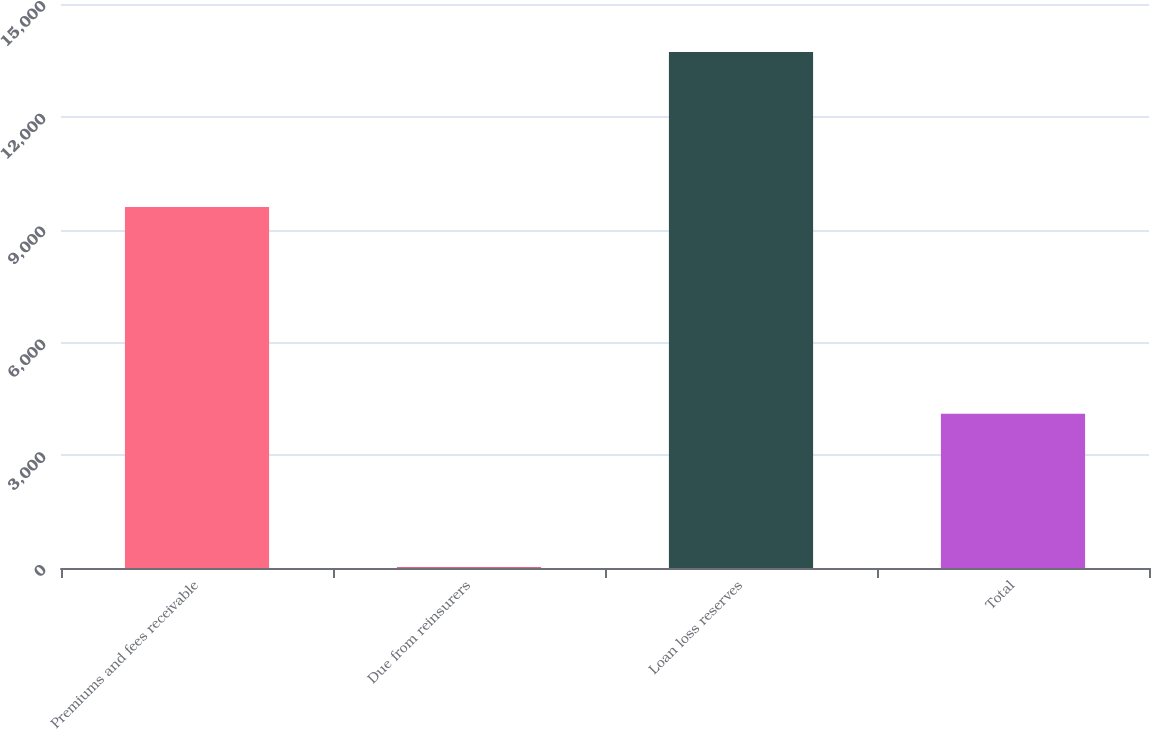<chart> <loc_0><loc_0><loc_500><loc_500><bar_chart><fcel>Premiums and fees receivable<fcel>Due from reinsurers<fcel>Loan loss reserves<fcel>Total<nl><fcel>9598<fcel>22<fcel>13723<fcel>4103<nl></chart> 